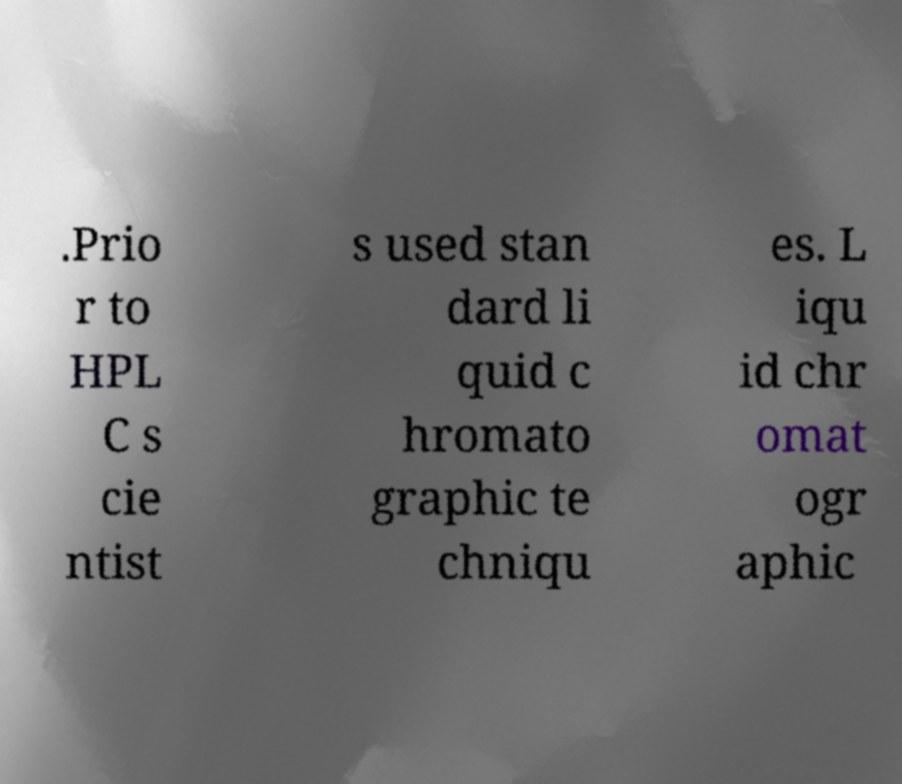Can you read and provide the text displayed in the image?This photo seems to have some interesting text. Can you extract and type it out for me? .Prio r to HPL C s cie ntist s used stan dard li quid c hromato graphic te chniqu es. L iqu id chr omat ogr aphic 